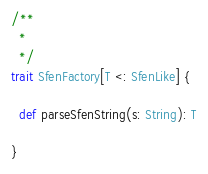<code> <loc_0><loc_0><loc_500><loc_500><_Scala_>/**
  *
  */
trait SfenFactory[T <: SfenLike] {

  def parseSfenString(s: String): T

}
</code> 